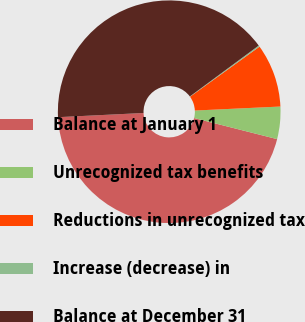Convert chart to OTSL. <chart><loc_0><loc_0><loc_500><loc_500><pie_chart><fcel>Balance at January 1<fcel>Unrecognized tax benefits<fcel>Reductions in unrecognized tax<fcel>Increase (decrease) in<fcel>Balance at December 31<nl><fcel>45.27%<fcel>4.7%<fcel>9.2%<fcel>0.19%<fcel>40.65%<nl></chart> 